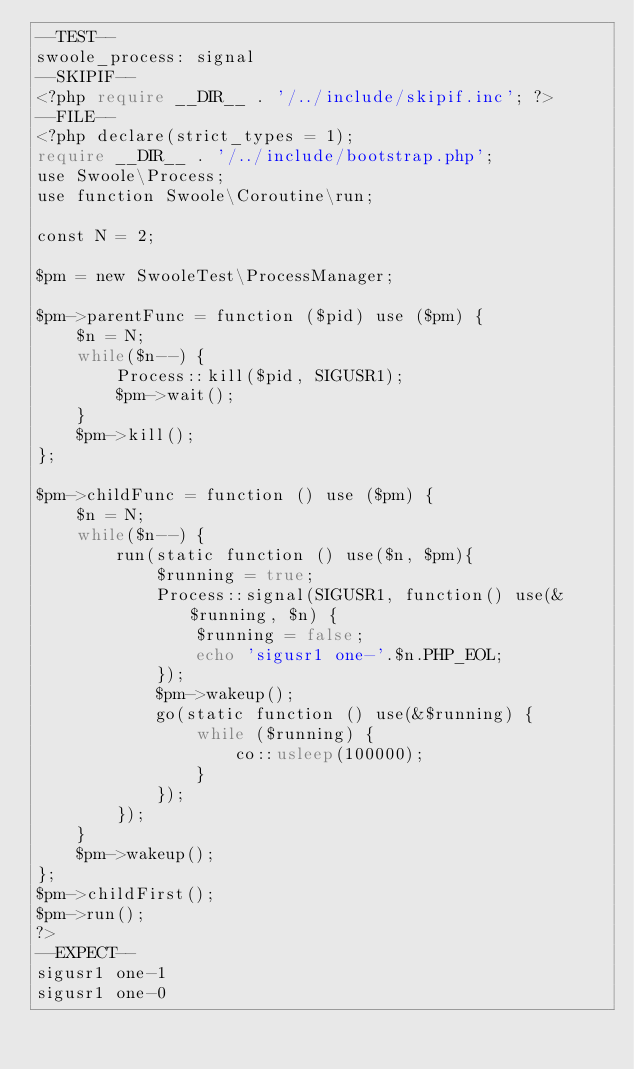Convert code to text. <code><loc_0><loc_0><loc_500><loc_500><_PHP_>--TEST--
swoole_process: signal
--SKIPIF--
<?php require __DIR__ . '/../include/skipif.inc'; ?>
--FILE--
<?php declare(strict_types = 1);
require __DIR__ . '/../include/bootstrap.php';
use Swoole\Process;
use function Swoole\Coroutine\run;

const N = 2;

$pm = new SwooleTest\ProcessManager;

$pm->parentFunc = function ($pid) use ($pm) {
    $n = N;
    while($n--) {
        Process::kill($pid, SIGUSR1);
        $pm->wait();
    }
    $pm->kill();
};

$pm->childFunc = function () use ($pm) {
    $n = N;
    while($n--) {
        run(static function () use($n, $pm){
            $running = true;
            Process::signal(SIGUSR1, function() use(&$running, $n) {
                $running = false;
                echo 'sigusr1 one-'.$n.PHP_EOL;
            });
            $pm->wakeup();
            go(static function () use(&$running) {
                while ($running) {
                    co::usleep(100000);
                }
            });
        });
    }
    $pm->wakeup();
};
$pm->childFirst();
$pm->run();
?>
--EXPECT--
sigusr1 one-1
sigusr1 one-0
</code> 